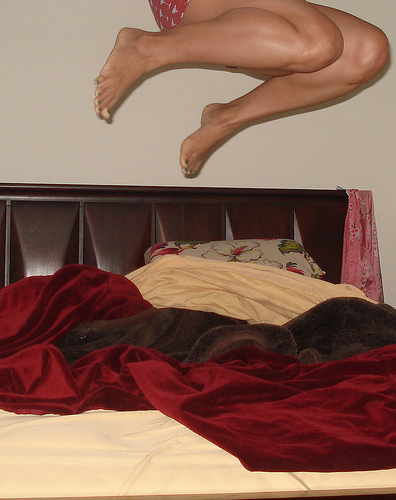<image>
Can you confirm if the legs is in front of the wall? Yes. The legs is positioned in front of the wall, appearing closer to the camera viewpoint. 